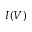Convert formula to latex. <formula><loc_0><loc_0><loc_500><loc_500>I ( V )</formula> 